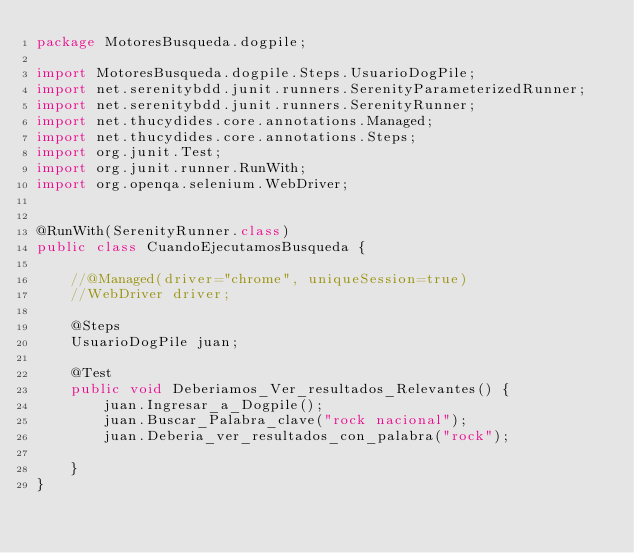<code> <loc_0><loc_0><loc_500><loc_500><_Java_>package MotoresBusqueda.dogpile;

import MotoresBusqueda.dogpile.Steps.UsuarioDogPile;
import net.serenitybdd.junit.runners.SerenityParameterizedRunner;
import net.serenitybdd.junit.runners.SerenityRunner;
import net.thucydides.core.annotations.Managed;
import net.thucydides.core.annotations.Steps;
import org.junit.Test;
import org.junit.runner.RunWith;
import org.openqa.selenium.WebDriver;


@RunWith(SerenityRunner.class)
public class CuandoEjecutamosBusqueda {

    //@Managed(driver="chrome", uniqueSession=true)
    //WebDriver driver;

    @Steps
    UsuarioDogPile juan;

    @Test
    public void Deberiamos_Ver_resultados_Relevantes() {
        juan.Ingresar_a_Dogpile();
        juan.Buscar_Palabra_clave("rock nacional");
        juan.Deberia_ver_resultados_con_palabra("rock");

    }
}
</code> 